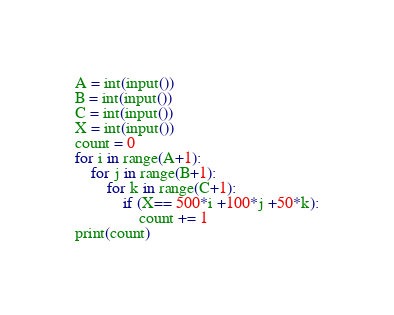<code> <loc_0><loc_0><loc_500><loc_500><_Python_>A = int(input())
B = int(input())
C = int(input())
X = int(input())
count = 0
for i in range(A+1):
    for j in range(B+1):
        for k in range(C+1):
            if (X== 500*i +100*j +50*k):
                count += 1
print(count)</code> 